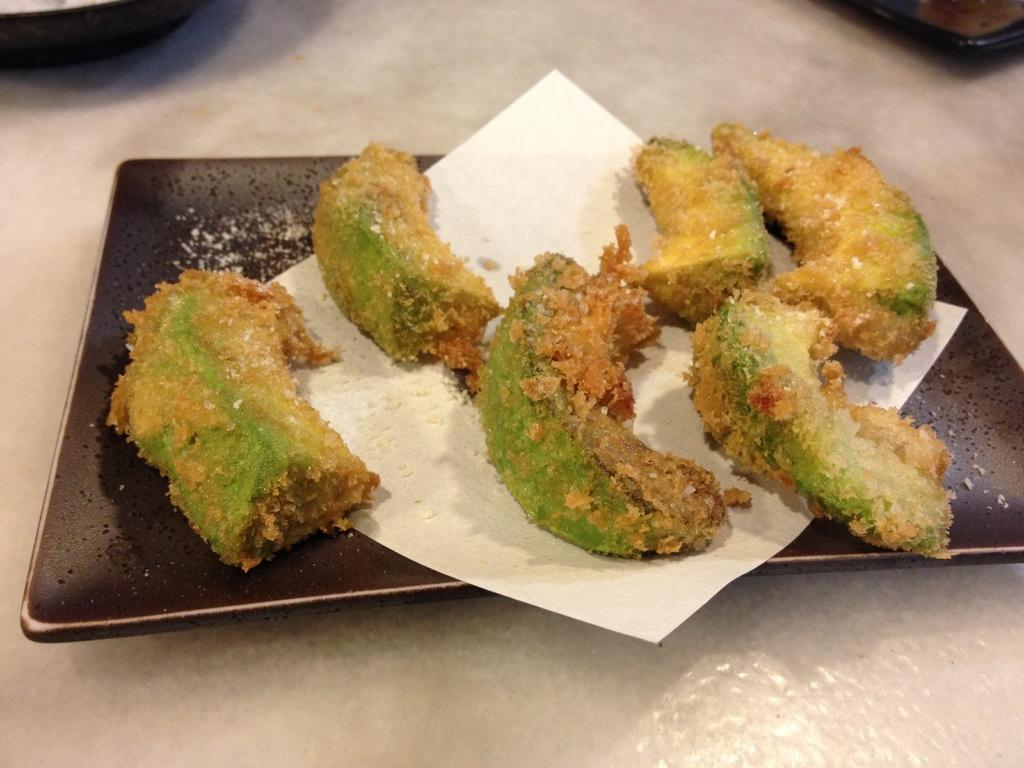What is the surface on which the food items are placed in the image? The food items are on a plate in the image. What is the plate resting on? The plate is on a platform in the image. How are the food items arranged in the image? The food items are on a tissue paper on the plate. Are there any objects on the platform besides the plate? Yes, there are objects on the platform at the top in the image. What type of instrument is being played by the boys in the image? There are no boys or instruments present in the image. What news headline is visible on the platform in the image? There is no news headline visible in the image; it features food items on a plate. 